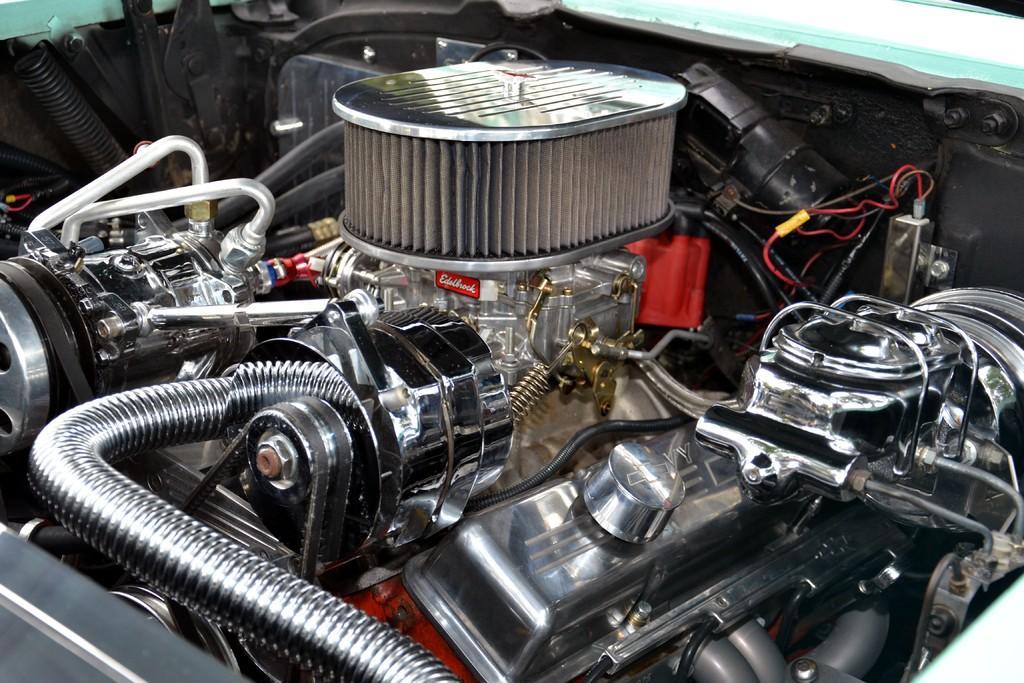How would you summarize this image in a sentence or two? In this picture we can see a close view of the car engine. In the center there is an air filter and some pipes. In the front bottom side there is a manifold and exhaust pipes. On the right corner we can see the black color alternators and red wires. 